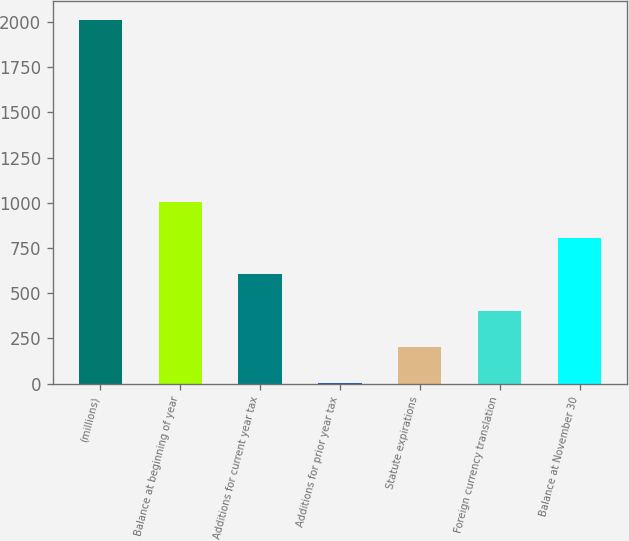<chart> <loc_0><loc_0><loc_500><loc_500><bar_chart><fcel>(millions)<fcel>Balance at beginning of year<fcel>Additions for current year tax<fcel>Additions for prior year tax<fcel>Statute expirations<fcel>Foreign currency translation<fcel>Balance at November 30<nl><fcel>2014<fcel>1007.35<fcel>604.69<fcel>0.7<fcel>202.03<fcel>403.36<fcel>806.02<nl></chart> 